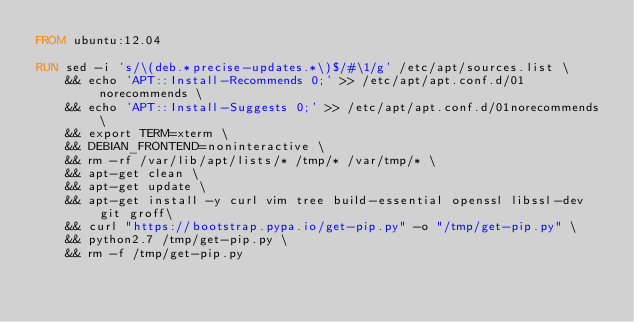Convert code to text. <code><loc_0><loc_0><loc_500><loc_500><_Dockerfile_>FROM ubuntu:12.04

RUN sed -i 's/\(deb.*precise-updates.*\)$/#\1/g' /etc/apt/sources.list \
    && echo 'APT::Install-Recommends 0;' >> /etc/apt/apt.conf.d/01norecommends \
    && echo 'APT::Install-Suggests 0;' >> /etc/apt/apt.conf.d/01norecommends \
    && export TERM=xterm \
    && DEBIAN_FRONTEND=noninteractive \
    && rm -rf /var/lib/apt/lists/* /tmp/* /var/tmp/* \
    && apt-get clean \
    && apt-get update \
    && apt-get install -y curl vim tree build-essential openssl libssl-dev git groff\
    && curl "https://bootstrap.pypa.io/get-pip.py" -o "/tmp/get-pip.py" \
    && python2.7 /tmp/get-pip.py \
    && rm -f /tmp/get-pip.py
</code> 